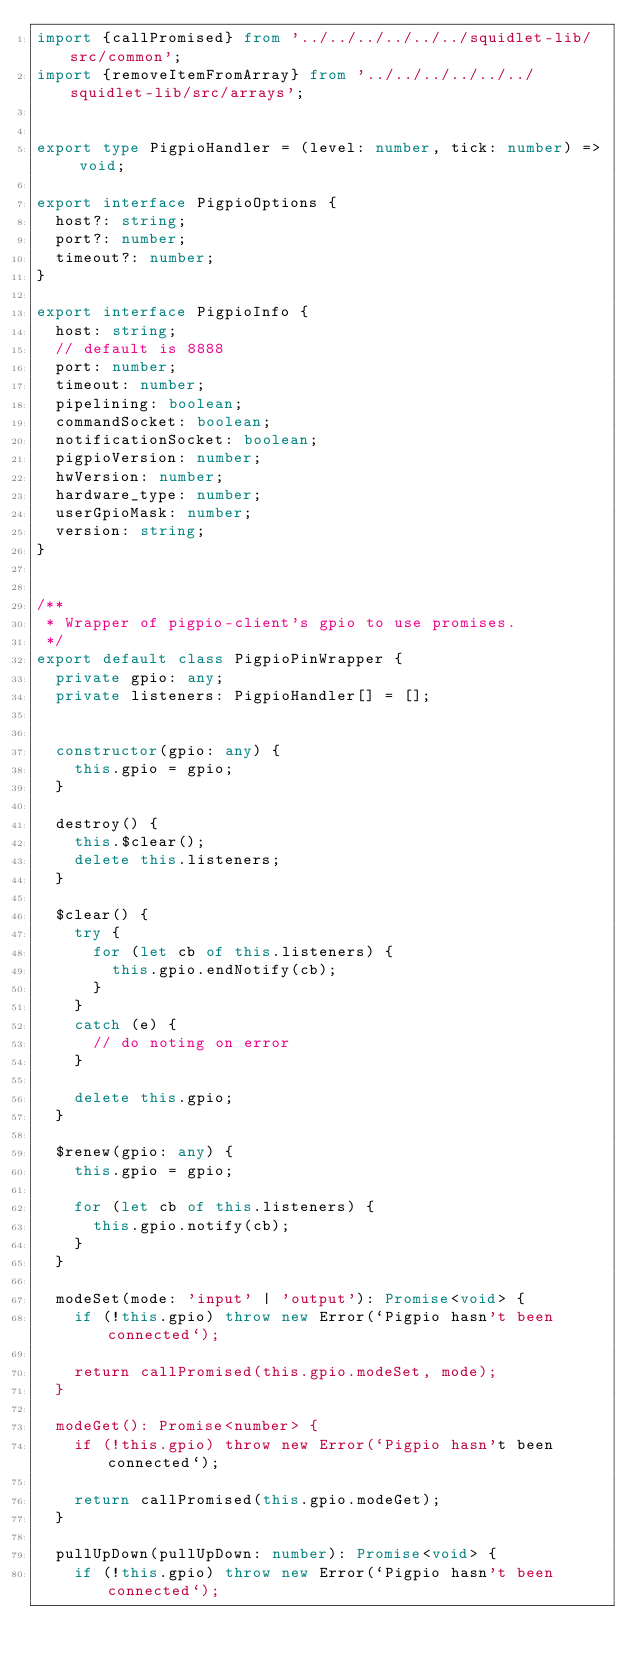<code> <loc_0><loc_0><loc_500><loc_500><_TypeScript_>import {callPromised} from '../../../../../../squidlet-lib/src/common';
import {removeItemFromArray} from '../../../../../../squidlet-lib/src/arrays';


export type PigpioHandler = (level: number, tick: number) => void;

export interface PigpioOptions {
  host?: string;
  port?: number;
  timeout?: number;
}

export interface PigpioInfo {
  host: string;
  // default is 8888
  port: number;
  timeout: number;
  pipelining: boolean;
  commandSocket: boolean;
  notificationSocket: boolean;
  pigpioVersion: number;
  hwVersion: number;
  hardware_type: number;
  userGpioMask: number;
  version: string;
}


/**
 * Wrapper of pigpio-client's gpio to use promises.
 */
export default class PigpioPinWrapper {
  private gpio: any;
  private listeners: PigpioHandler[] = [];


  constructor(gpio: any) {
    this.gpio = gpio;
  }

  destroy() {
    this.$clear();
    delete this.listeners;
  }

  $clear() {
    try {
      for (let cb of this.listeners) {
        this.gpio.endNotify(cb);
      }
    }
    catch (e) {
      // do noting on error
    }

    delete this.gpio;
  }

  $renew(gpio: any) {
    this.gpio = gpio;

    for (let cb of this.listeners) {
      this.gpio.notify(cb);
    }
  }

  modeSet(mode: 'input' | 'output'): Promise<void> {
    if (!this.gpio) throw new Error(`Pigpio hasn't been connected`);

    return callPromised(this.gpio.modeSet, mode);
  }

  modeGet(): Promise<number> {
    if (!this.gpio) throw new Error(`Pigpio hasn't been connected`);

    return callPromised(this.gpio.modeGet);
  }

  pullUpDown(pullUpDown: number): Promise<void> {
    if (!this.gpio) throw new Error(`Pigpio hasn't been connected`);
</code> 